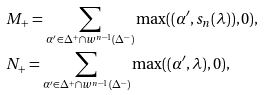<formula> <loc_0><loc_0><loc_500><loc_500>& M _ { + } = \sum _ { \alpha ^ { \prime } \in \Delta ^ { + } \cap w ^ { n - 1 } ( \Delta ^ { - } ) } \max ( ( \alpha ^ { \prime } , s _ { n } ( \lambda ) ) , 0 ) , \\ & N _ { + } = \sum _ { \alpha ^ { \prime } \in \Delta ^ { + } \cap w ^ { n - 1 } ( \Delta ^ { - } ) } \max ( ( \alpha ^ { \prime } , \lambda ) , 0 ) ,</formula> 